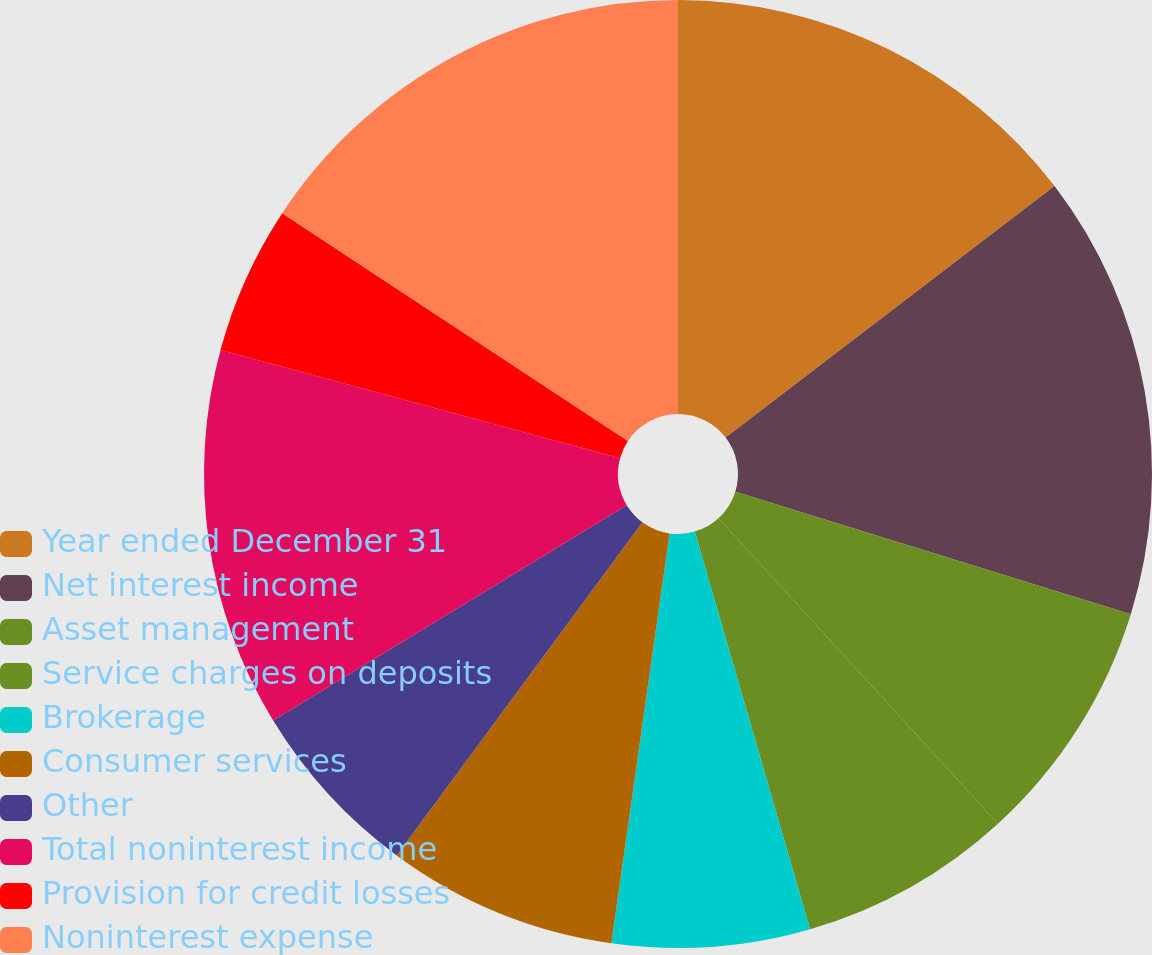Convert chart to OTSL. <chart><loc_0><loc_0><loc_500><loc_500><pie_chart><fcel>Year ended December 31<fcel>Net interest income<fcel>Asset management<fcel>Service charges on deposits<fcel>Brokerage<fcel>Consumer services<fcel>Other<fcel>Total noninterest income<fcel>Provision for credit losses<fcel>Noninterest expense<nl><fcel>14.61%<fcel>15.17%<fcel>8.43%<fcel>7.3%<fcel>6.74%<fcel>7.87%<fcel>6.18%<fcel>12.92%<fcel>5.06%<fcel>15.73%<nl></chart> 